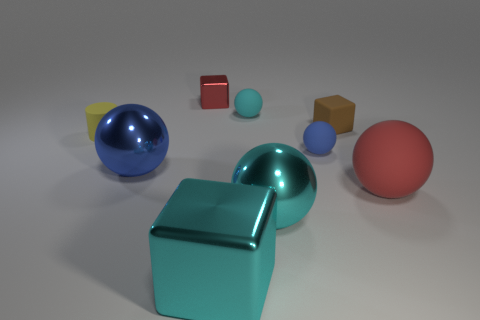What color is the cube that is the same size as the red rubber thing? cyan 